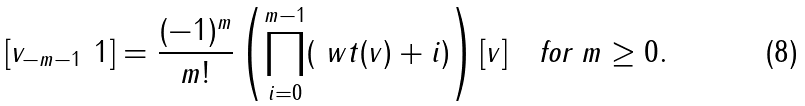<formula> <loc_0><loc_0><loc_500><loc_500>[ v _ { - m - 1 } \ 1 ] = \frac { ( - 1 ) ^ { m } } { m ! } \left ( \prod _ { i = 0 } ^ { m - 1 } ( \ w t ( v ) + i ) \right ) [ v ] \quad \text {for } m \geq 0 .</formula> 